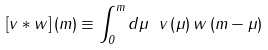Convert formula to latex. <formula><loc_0><loc_0><loc_500><loc_500>\left [ v * w \right ] \left ( m \right ) \equiv \int _ { 0 } ^ { m } d \mu \ v \left ( \mu \right ) w \left ( m - \mu \right )</formula> 